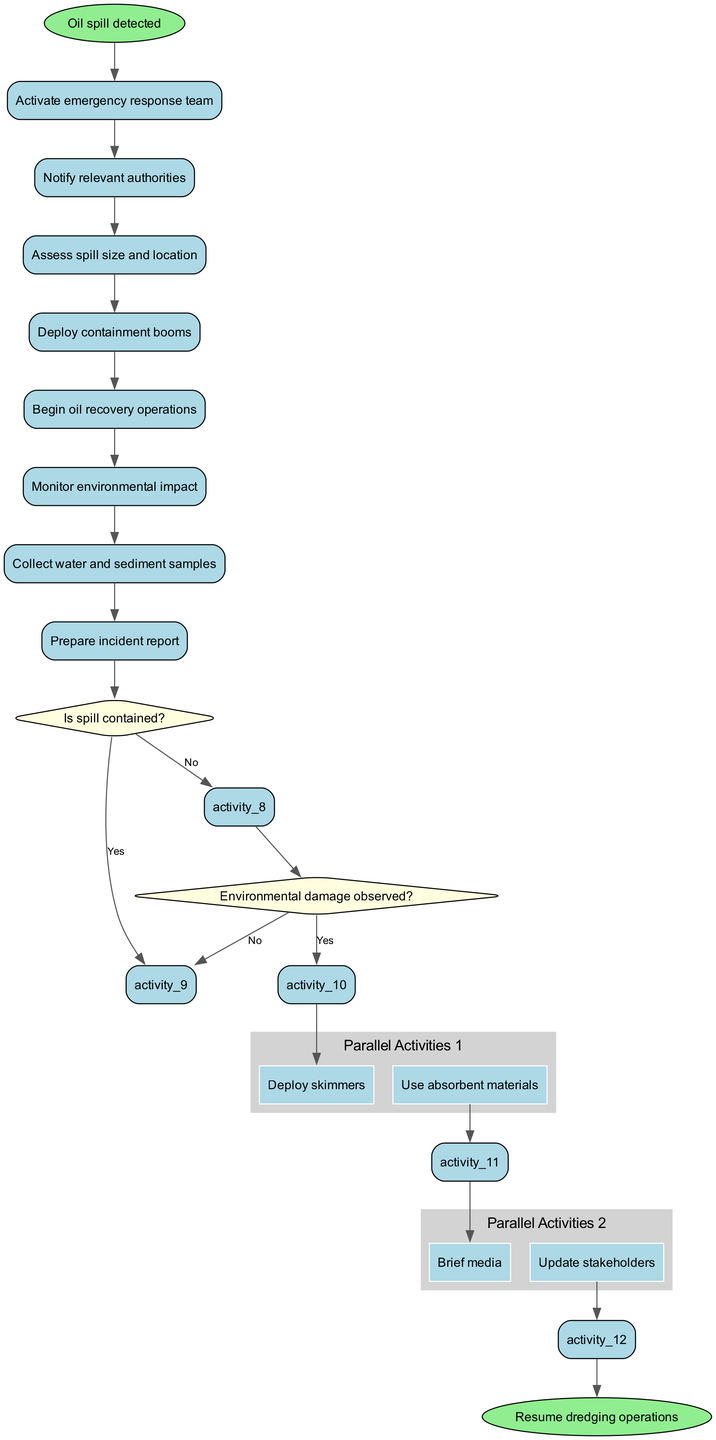What is the initial node of the diagram? The initial node is indicated as "Oil spill detected," which is the starting point of the emergency response process in the diagram.
Answer: Oil spill detected How many activities are there in total? The activities listed in the diagram include 8 distinct actions to take during the emergency response procedure.
Answer: 8 What decision follows the activity "Begin oil recovery operations"? After "Begin oil recovery operations," the next step in the sequence is the decision node asking "Is spill contained?" which assesses the status of the spill.
Answer: Is spill contained? What are the parallel activities listed in the diagram? The diagram includes two sets of parallel activities: one set contains "Deploy skimmers" and "Use absorbent materials," while the other set features "Brief media" and "Update stakeholders."
Answer: Deploy skimmers, Use absorbent materials; Brief media, Update stakeholders If the answer to "Is spill contained?" is No, what is the next action taken? If the response to "Is spill contained?" is No, then the procedure calls for requesting additional resources to manage the spill effectively.
Answer: Request additional resources What happens after "Monitor environmental impact"? Following "Monitor environmental impact," the decision "Environmental damage observed?" is made to determine the next steps based on the impacts assessed.
Answer: Environmental damage observed? What is the final node of the diagram? The final node concludes the emergency response process, leading back to regular operations, specifically labeled as "Resume dredging operations."
Answer: Resume dredging operations In what specific scenario would "Implement mitigation measures" be executed? "Implement mitigation measures" is executed if the decision made at the node "Environmental damage observed?" is answered with Yes, indicating that environmental impacts have been detected.
Answer: Environmental damage observed? Yes What activity occurs after collecting water and sediment samples? After "Collect water and sediment samples," the diagram proceeds with the preparation of the "Prepare incident report" activity, summarizing the events and actions taken.
Answer: Prepare incident report 